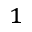Convert formula to latex. <formula><loc_0><loc_0><loc_500><loc_500>^ { 1 }</formula> 